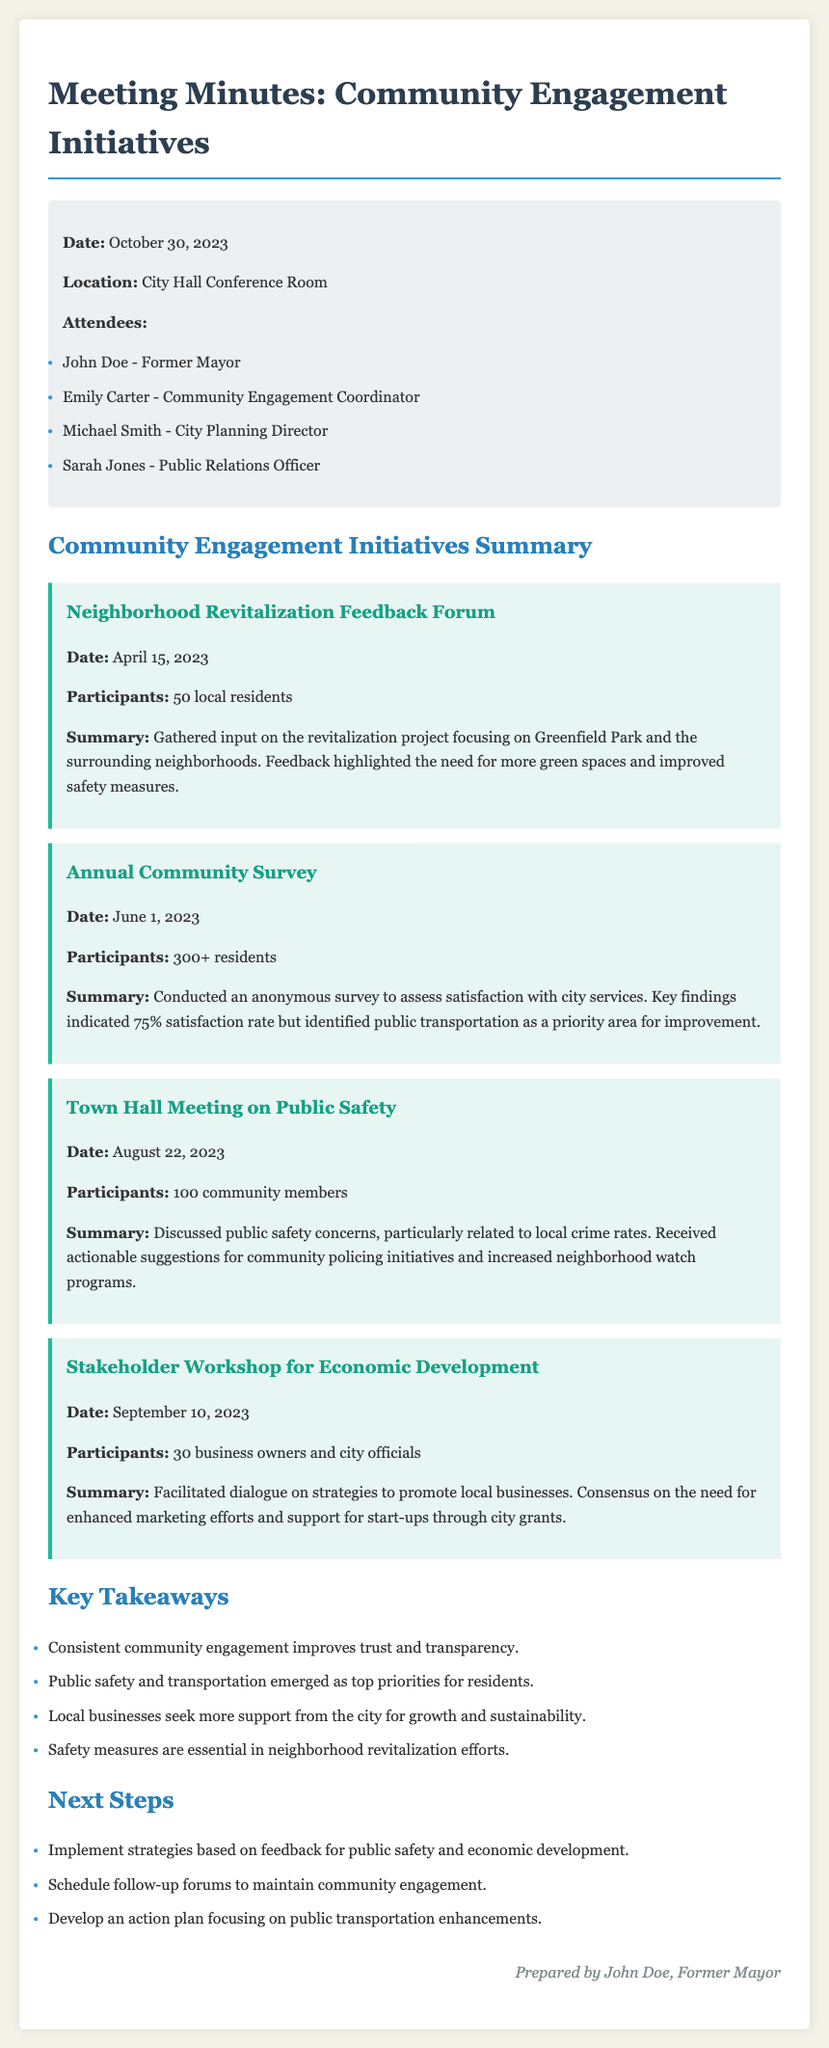What is the date of the Neighborhood Revitalization Feedback Forum? The date is stated in the initiative section for the Neighborhood Revitalization Feedback Forum.
Answer: April 15, 2023 How many participants attended the Annual Community Survey? The number of participants is provided in the summary of the Annual Community Survey initiative.
Answer: 300+ What was a key finding of the Town Hall Meeting on Public Safety? The key finding is mentioned in the summary of the Town Hall Meeting initiative regarding public safety concerns.
Answer: Actionable suggestions for community policing initiatives Who facilitated the Stakeholder Workshop for Economic Development? The facilitator is subtly indicated as the city officials and business owners involved in the dialogue.
Answer: City officials What are two top priorities identified by residents? The top priorities are listed in the Key Takeaways section after discussing community engagement initiatives.
Answer: Public safety and transportation What is one of the next steps mentioned after the community engagement initiatives? The next steps are outlined clearly in the Next Steps section of the document.
Answer: Implement strategies based on feedback for public safety and economic development How many community members participated in the Town Hall Meeting? The number of participants is available in the summary of the Town Hall Meeting initiative.
Answer: 100 What is the main purpose of the Annual Community Survey? The purpose is stated in the summary of the Annual Community Survey initiative.
Answer: Assess satisfaction with city services 